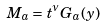Convert formula to latex. <formula><loc_0><loc_0><loc_500><loc_500>M _ { a } = t ^ { \nu } G _ { a } ( y )</formula> 